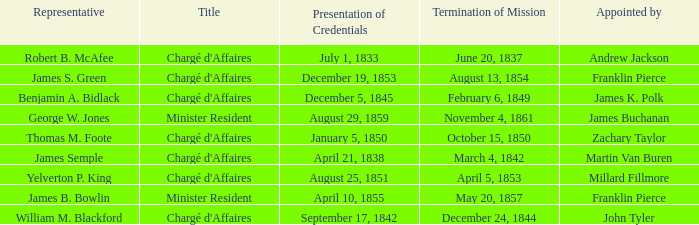What's the Termination of Mission listed that has a Presentation of Credentials for August 29, 1859? November 4, 1861. Parse the table in full. {'header': ['Representative', 'Title', 'Presentation of Credentials', 'Termination of Mission', 'Appointed by'], 'rows': [['Robert B. McAfee', "Chargé d'Affaires", 'July 1, 1833', 'June 20, 1837', 'Andrew Jackson'], ['James S. Green', "Chargé d'Affaires", 'December 19, 1853', 'August 13, 1854', 'Franklin Pierce'], ['Benjamin A. Bidlack', "Chargé d'Affaires", 'December 5, 1845', 'February 6, 1849', 'James K. Polk'], ['George W. Jones', 'Minister Resident', 'August 29, 1859', 'November 4, 1861', 'James Buchanan'], ['Thomas M. Foote', "Chargé d'Affaires", 'January 5, 1850', 'October 15, 1850', 'Zachary Taylor'], ['James Semple', "Chargé d'Affaires", 'April 21, 1838', 'March 4, 1842', 'Martin Van Buren'], ['Yelverton P. King', "Chargé d'Affaires", 'August 25, 1851', 'April 5, 1853', 'Millard Fillmore'], ['James B. Bowlin', 'Minister Resident', 'April 10, 1855', 'May 20, 1857', 'Franklin Pierce'], ['William M. Blackford', "Chargé d'Affaires", 'September 17, 1842', 'December 24, 1844', 'John Tyler']]} 